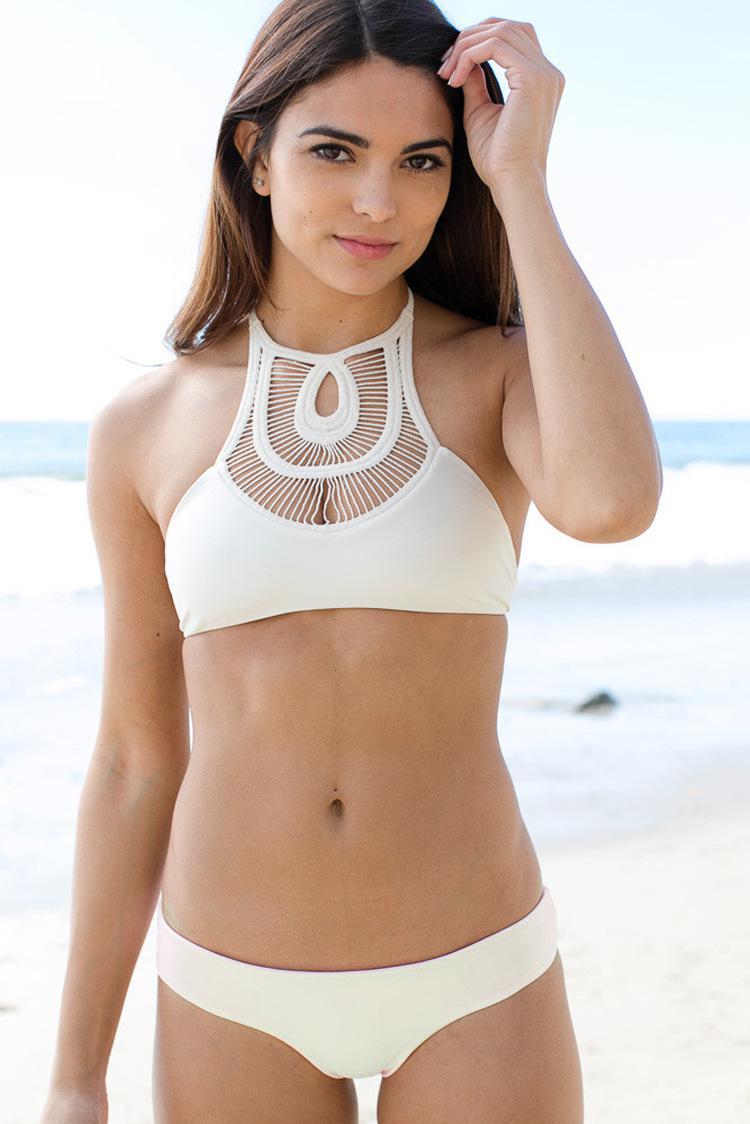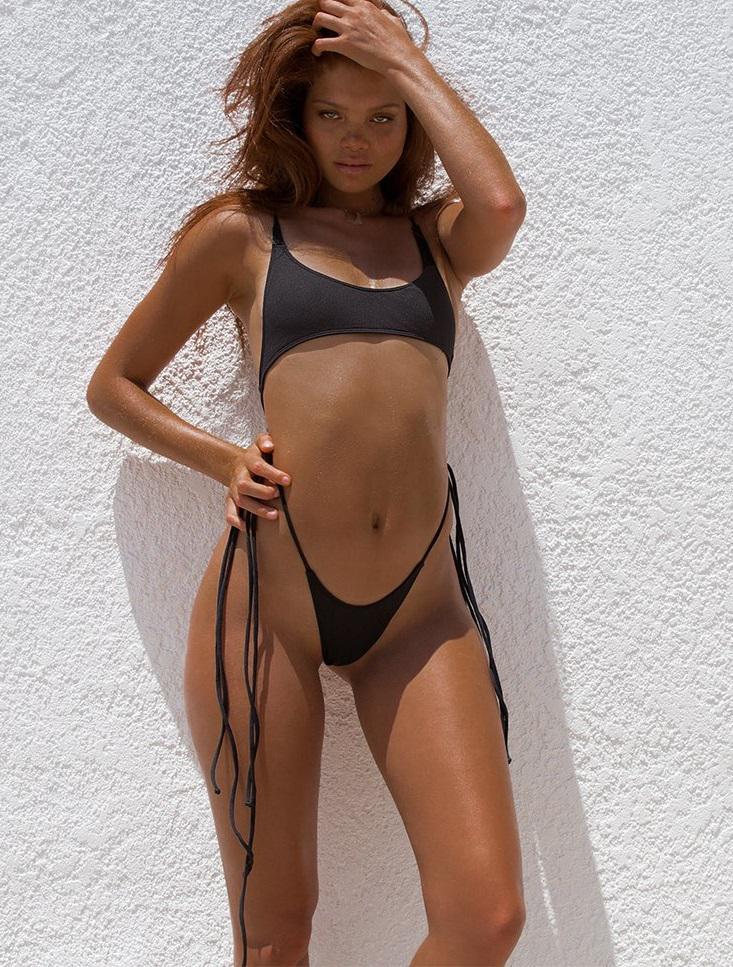The first image is the image on the left, the second image is the image on the right. Evaluate the accuracy of this statement regarding the images: "The bikini belonging to the woman on the left is only one color: white.". Is it true? Answer yes or no. Yes. 